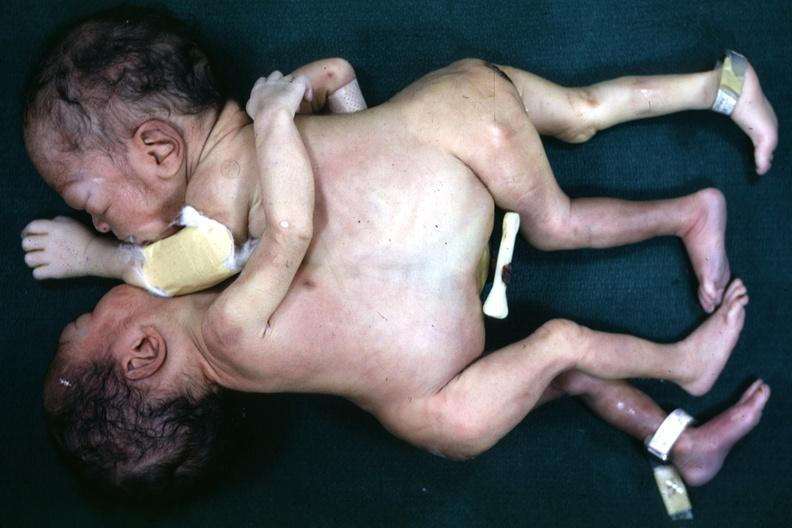s siamese twins present?
Answer the question using a single word or phrase. Yes 